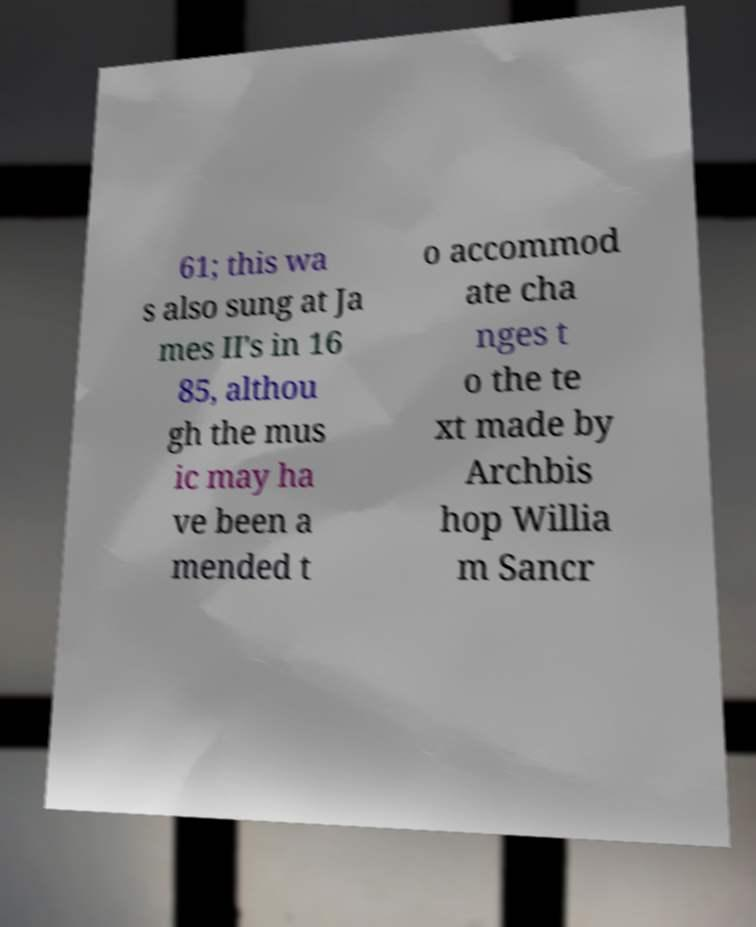Can you read and provide the text displayed in the image?This photo seems to have some interesting text. Can you extract and type it out for me? 61; this wa s also sung at Ja mes II's in 16 85, althou gh the mus ic may ha ve been a mended t o accommod ate cha nges t o the te xt made by Archbis hop Willia m Sancr 